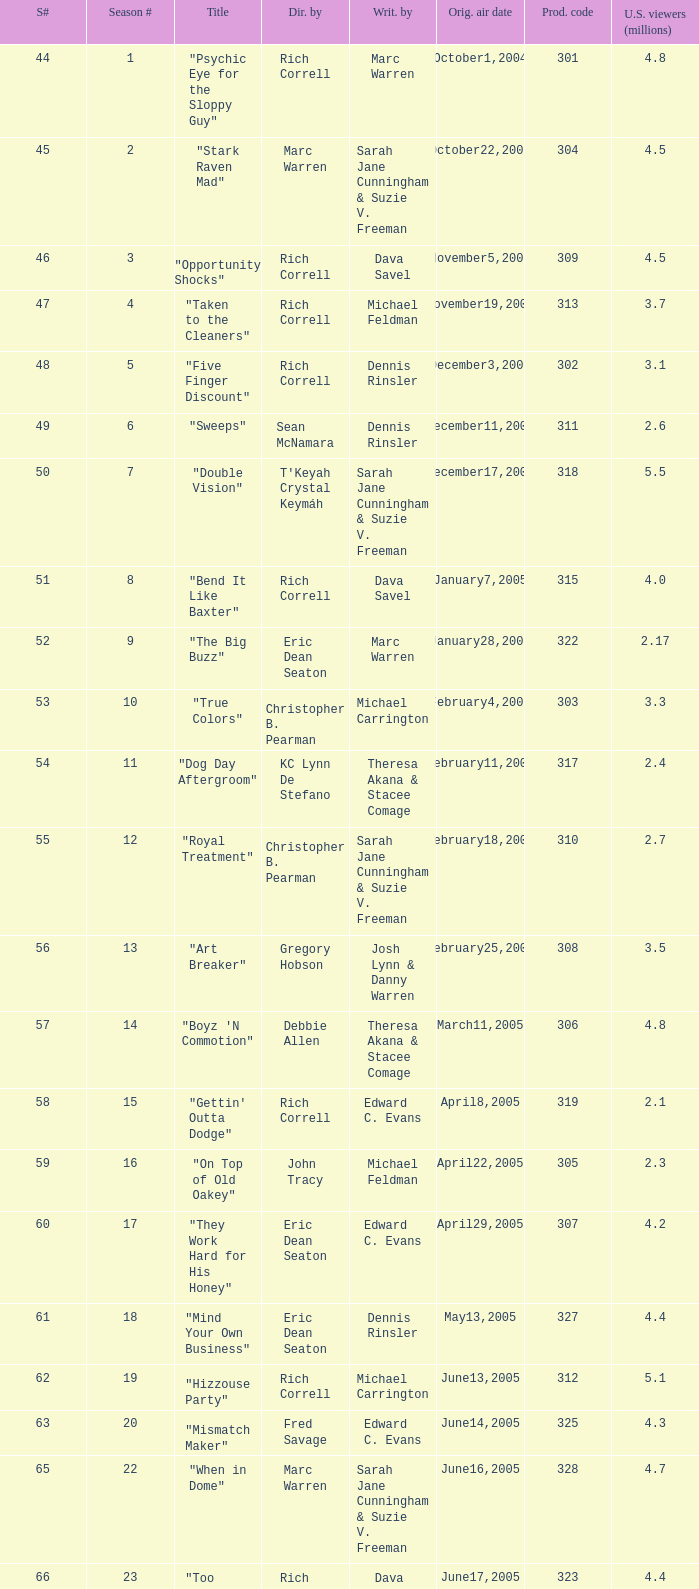What was the production code of the episode directed by Rondell Sheridan?  332.0. 